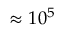Convert formula to latex. <formula><loc_0><loc_0><loc_500><loc_500>\approx 1 0 ^ { 5 }</formula> 